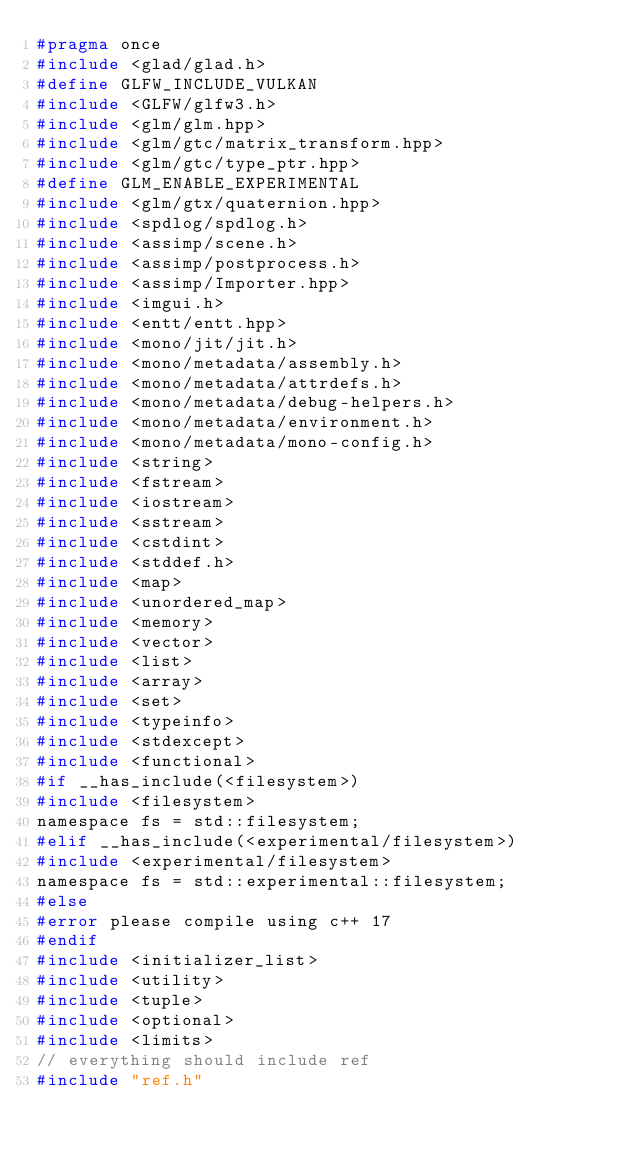<code> <loc_0><loc_0><loc_500><loc_500><_C_>#pragma once
#include <glad/glad.h>
#define GLFW_INCLUDE_VULKAN
#include <GLFW/glfw3.h>
#include <glm/glm.hpp>
#include <glm/gtc/matrix_transform.hpp>
#include <glm/gtc/type_ptr.hpp>
#define GLM_ENABLE_EXPERIMENTAL
#include <glm/gtx/quaternion.hpp>
#include <spdlog/spdlog.h>
#include <assimp/scene.h>
#include <assimp/postprocess.h>
#include <assimp/Importer.hpp>
#include <imgui.h>
#include <entt/entt.hpp>
#include <mono/jit/jit.h>
#include <mono/metadata/assembly.h>
#include <mono/metadata/attrdefs.h>
#include <mono/metadata/debug-helpers.h>
#include <mono/metadata/environment.h>
#include <mono/metadata/mono-config.h>
#include <string>
#include <fstream>
#include <iostream>
#include <sstream>
#include <cstdint>
#include <stddef.h>
#include <map>
#include <unordered_map>
#include <memory>
#include <vector>
#include <list>
#include <array>
#include <set>
#include <typeinfo>
#include <stdexcept>
#include <functional>
#if __has_include(<filesystem>)
#include <filesystem>
namespace fs = std::filesystem;
#elif __has_include(<experimental/filesystem>)
#include <experimental/filesystem>
namespace fs = std::experimental::filesystem;
#else
#error please compile using c++ 17
#endif
#include <initializer_list>
#include <utility>
#include <tuple>
#include <optional>
#include <limits>
// everything should include ref
#include "ref.h"</code> 